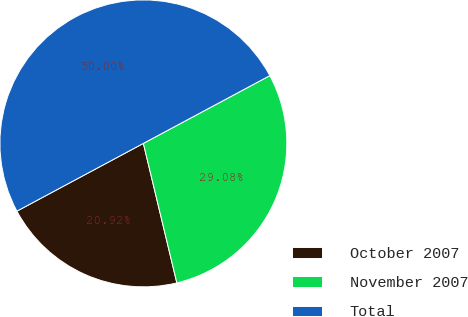Convert chart to OTSL. <chart><loc_0><loc_0><loc_500><loc_500><pie_chart><fcel>October 2007<fcel>November 2007<fcel>Total<nl><fcel>20.92%<fcel>29.08%<fcel>50.0%<nl></chart> 